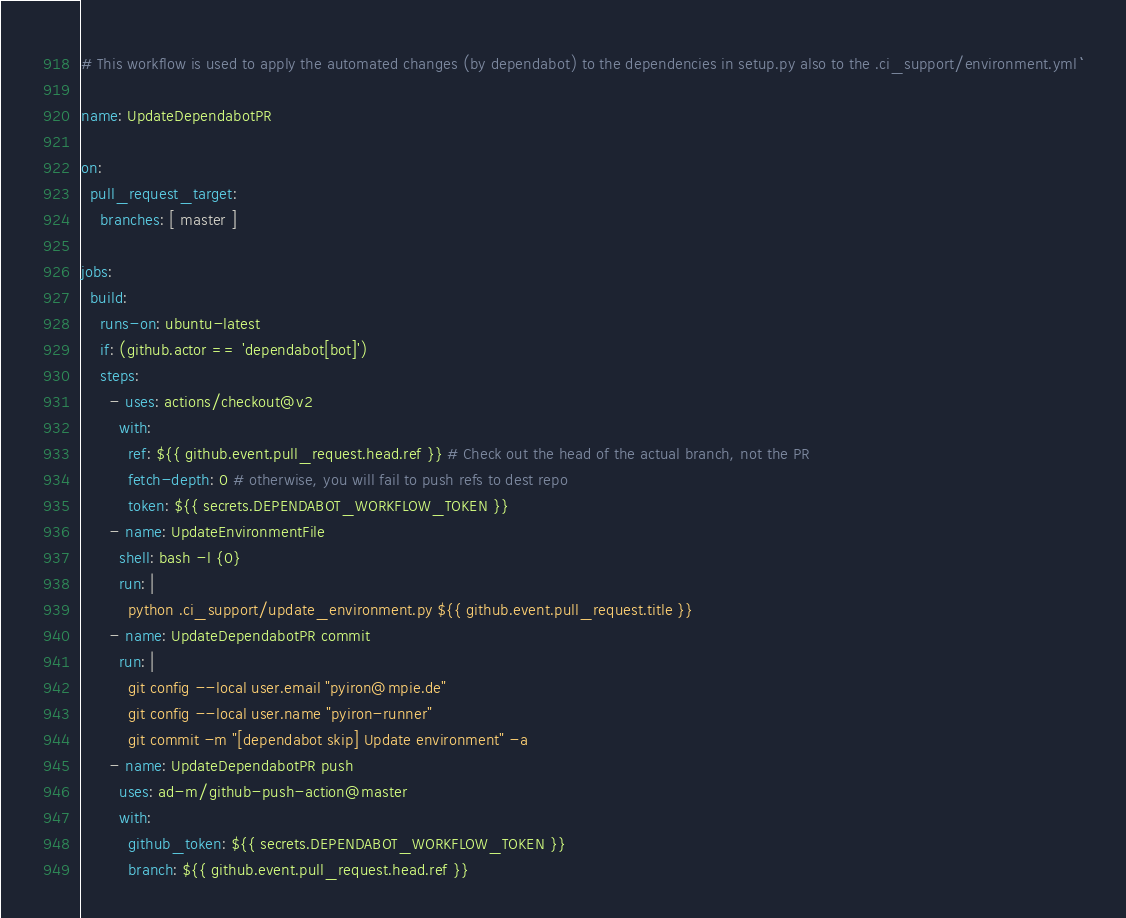<code> <loc_0><loc_0><loc_500><loc_500><_YAML_># This workflow is used to apply the automated changes (by dependabot) to the dependencies in setup.py also to the .ci_support/environment.yml ```

name: UpdateDependabotPR

on:
  pull_request_target:
    branches: [ master ]

jobs:
  build:
    runs-on: ubuntu-latest
    if: (github.actor == 'dependabot[bot]')
    steps:
      - uses: actions/checkout@v2
        with:
          ref: ${{ github.event.pull_request.head.ref }} # Check out the head of the actual branch, not the PR
          fetch-depth: 0 # otherwise, you will fail to push refs to dest repo
          token: ${{ secrets.DEPENDABOT_WORKFLOW_TOKEN }}
      - name: UpdateEnvironmentFile
        shell: bash -l {0}
        run: |
          python .ci_support/update_environment.py ${{ github.event.pull_request.title }}
      - name: UpdateDependabotPR commit
        run: |
          git config --local user.email "pyiron@mpie.de"
          git config --local user.name "pyiron-runner"
          git commit -m "[dependabot skip] Update environment" -a
      - name: UpdateDependabotPR push
        uses: ad-m/github-push-action@master
        with:
          github_token: ${{ secrets.DEPENDABOT_WORKFLOW_TOKEN }}
          branch: ${{ github.event.pull_request.head.ref }}
</code> 